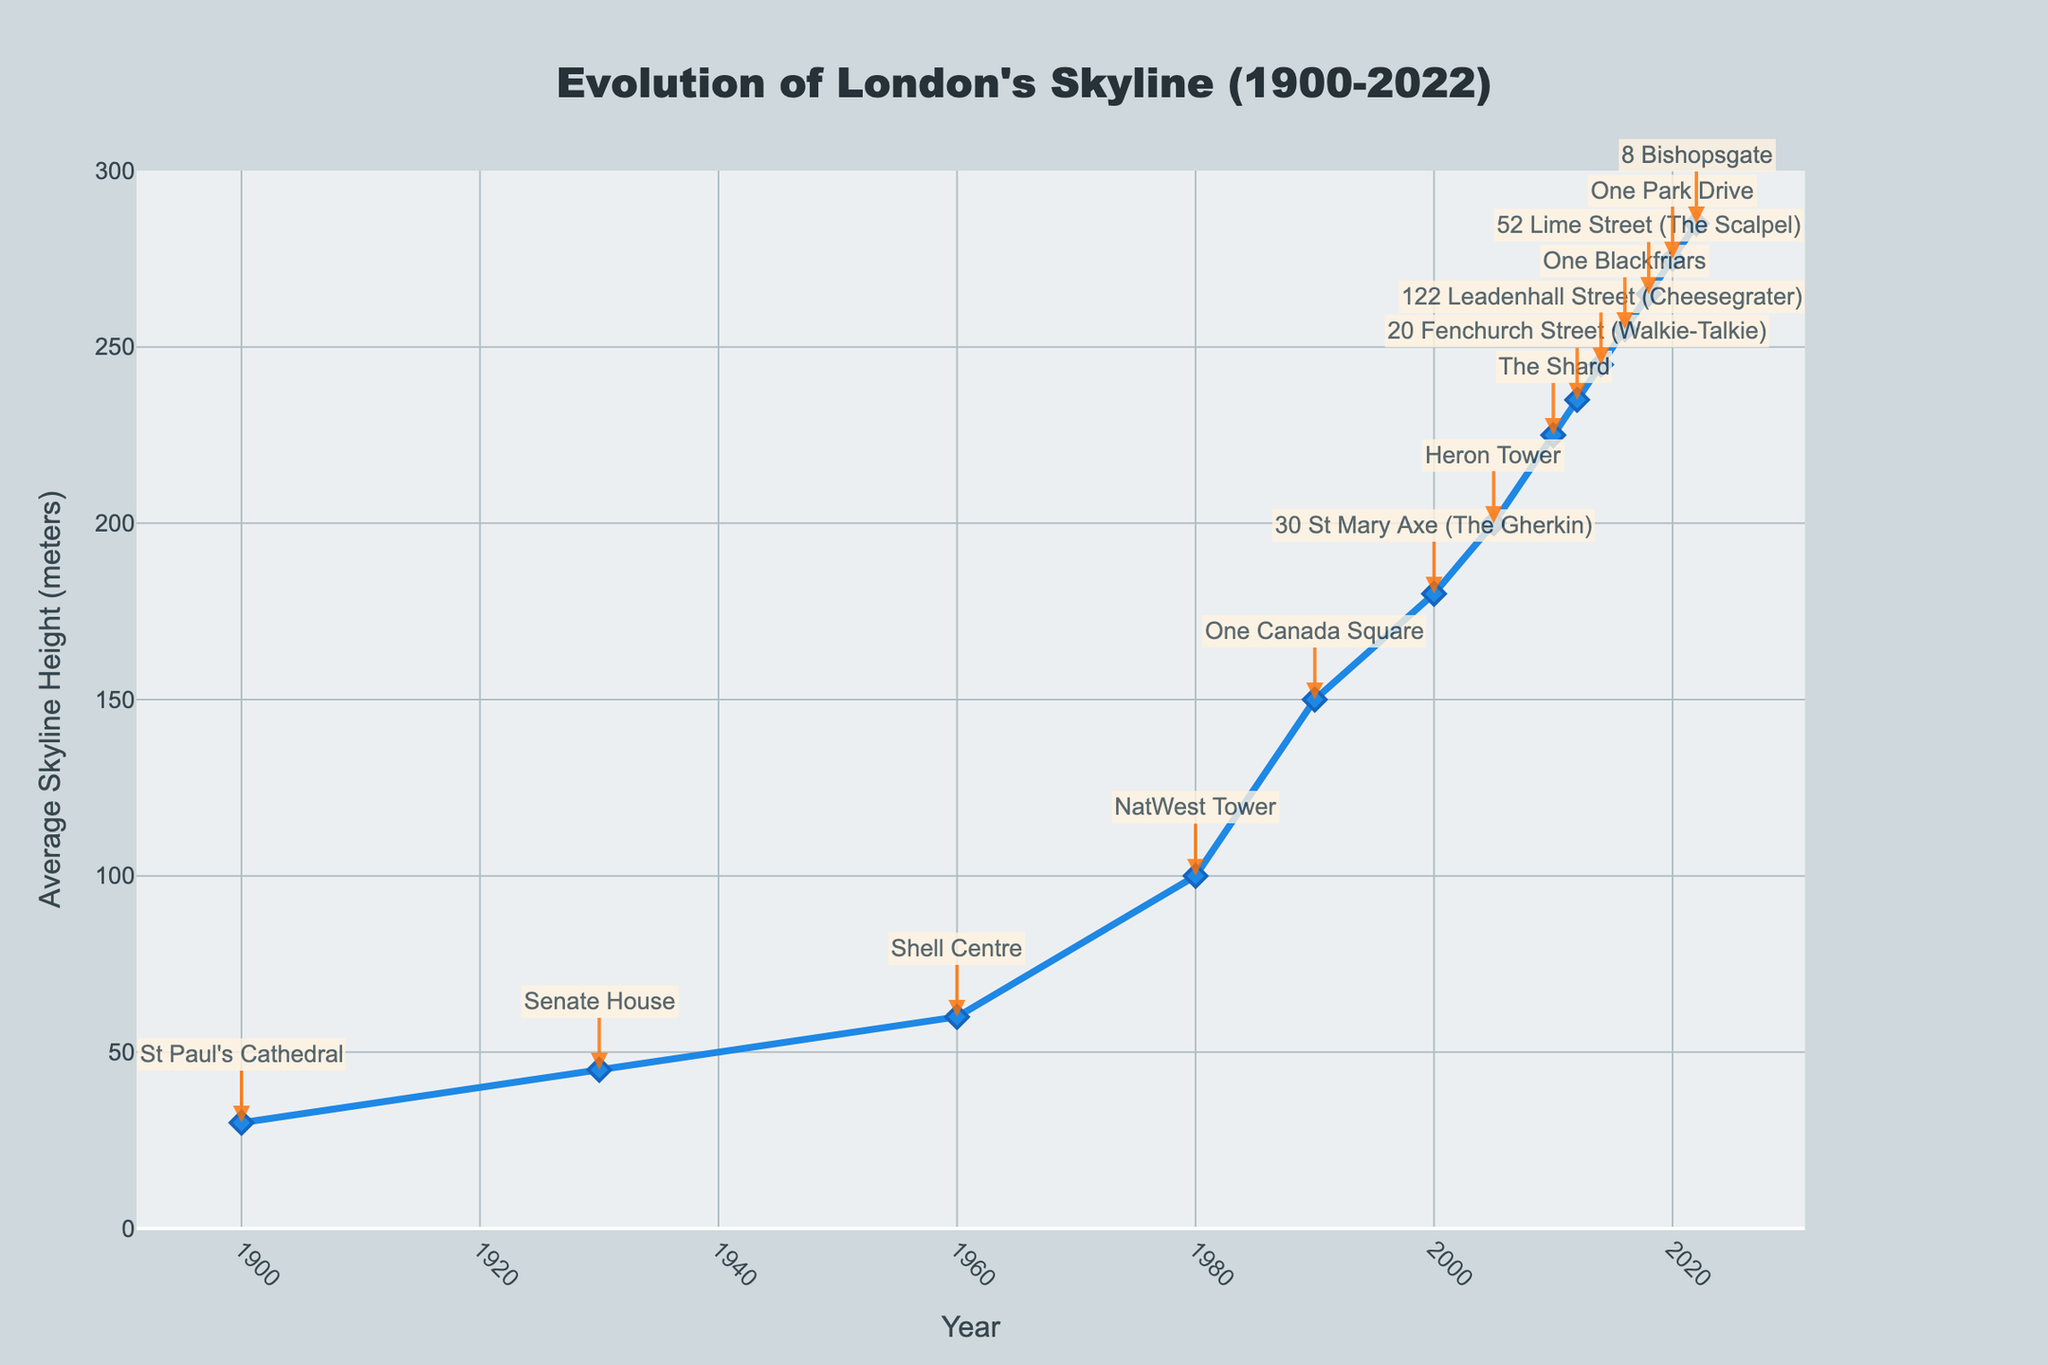What is the average skyline height in 1990? Find the year 1990 on the x-axis, trace directly upwards until you meet the line and note the corresponding height on the y-axis.
Answer: 150 meters Which year saw the introduction of The Shard? Locate "The Shard" in the annotations and identify the corresponding year on the x-axis.
Answer: 2010 Between 1930 and 1960, by how many meters did the average skyline height increase? Find the average skyline heights for 1930 and 1960 on the y-axis and calculate the difference: 60 - 45 = 15.
Answer: 15 meters Which skyscraper has the highest average skyline height recorded in the figure? Look for the highest point on the line and identify the skyscraper annotated at that point.
Answer: 8 Bishopsgate Compare the average skyline height of 1980 and 2000. Which year had a greater height, and by how much? Find the heights for 1980 and 2000 on the y-axis and calculate the difference: 180 - 100 = 80. 2000 is greater than 1980 by 80 meters.
Answer: 2000, 80 meters What was the rate of increase in average skyline height from 2016 to 2022? Find the heights for 2016 and 2022 and divide the difference by the number of years: (285 - 255) / (2022 - 2016) = 30 / 6 = 5 meters per year.
Answer: 5 meters per year Describe the visual trend of the skyline's average height from 2000 to 2022. Observe the line from 2000 to 2022, noting the direction and rate of change (it consistently rises, indicating a steady increase in height).
Answer: Steady increase What is the height difference between 'Shell Centre' and 'One Canada Square'? Find the heights for 'Shell Centre' in 1960 and 'One Canada Square' in 1990, and calculate the difference: 150 - 60 = 90.
Answer: 90 meters In which decade did the average skyline height see the most rapid increase? Compare the slopes of the line segments for each decade and identify the steepest slope.
Answer: 1990s Between "NatWest Tower" and "20 Fenchurch Street", which building came first and by how many years? Identify the years for "NatWest Tower" (1980) and "20 Fenchurch Street" (2012) and calculate the difference: 2012 - 1980 = 32 years. NatWest Tower came first.
Answer: NatWest Tower, 32 years 